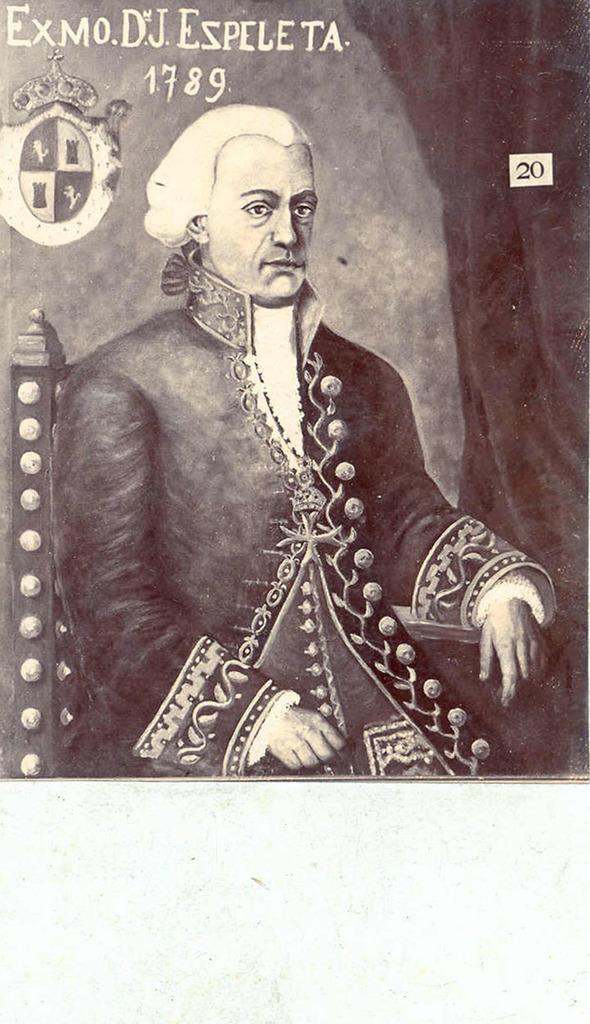What is depicted in the foreground of the poster? There is a painting of a man sitting on a chair in the foreground of the poster. What can be seen on the right side of the poster? There is a curtain on the right side of the poster. What is present on the wall in the poster? There is an object on the wall. What is written or displayed at the top of the poster? There is some text at the top of the poster. How many spiders are crawling on the man's neck in the poster? There are no spiders present in the poster, and the man's neck is not visible in the painting. 